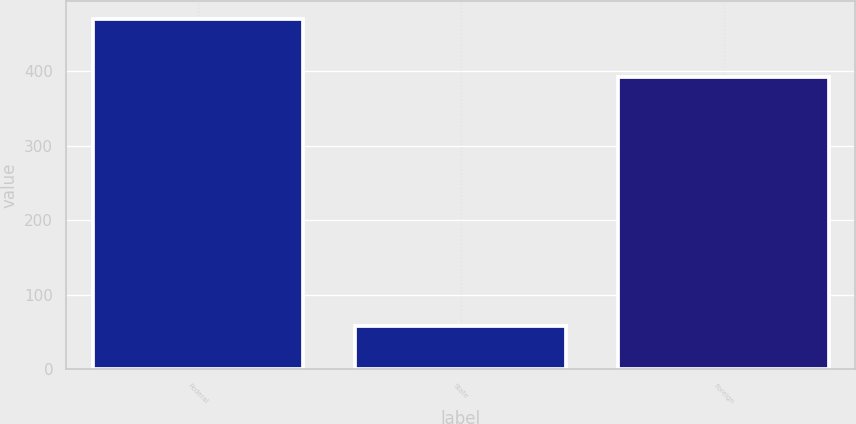Convert chart. <chart><loc_0><loc_0><loc_500><loc_500><bar_chart><fcel>Federal<fcel>State<fcel>Foreign<nl><fcel>469.9<fcel>58.4<fcel>391.8<nl></chart> 